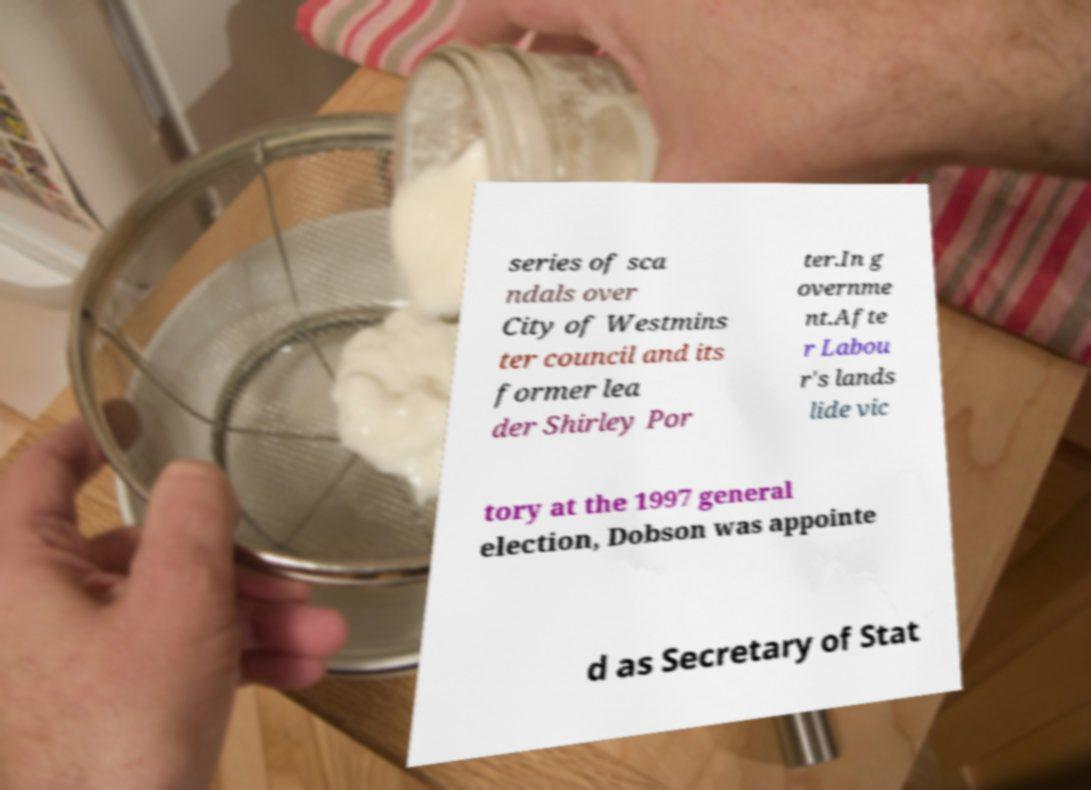Please identify and transcribe the text found in this image. series of sca ndals over City of Westmins ter council and its former lea der Shirley Por ter.In g overnme nt.Afte r Labou r's lands lide vic tory at the 1997 general election, Dobson was appointe d as Secretary of Stat 